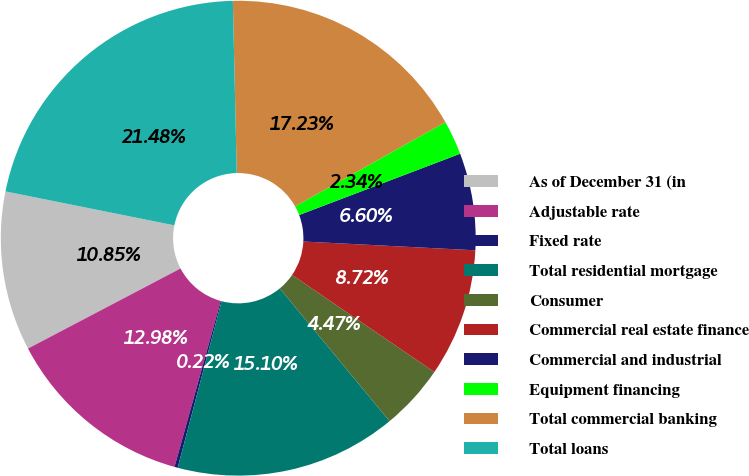Convert chart to OTSL. <chart><loc_0><loc_0><loc_500><loc_500><pie_chart><fcel>As of December 31 (in<fcel>Adjustable rate<fcel>Fixed rate<fcel>Total residential mortgage<fcel>Consumer<fcel>Commercial real estate finance<fcel>Commercial and industrial<fcel>Equipment financing<fcel>Total commercial banking<fcel>Total loans<nl><fcel>10.85%<fcel>12.98%<fcel>0.22%<fcel>15.1%<fcel>4.47%<fcel>8.72%<fcel>6.6%<fcel>2.34%<fcel>17.23%<fcel>21.48%<nl></chart> 